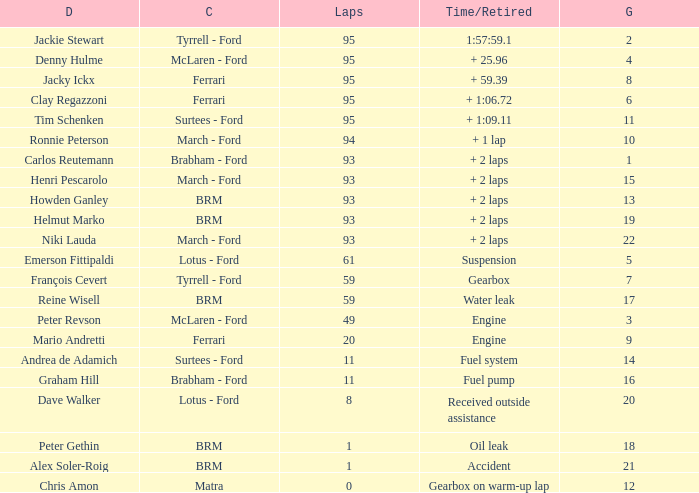How many grids does dave walker have? 1.0. 